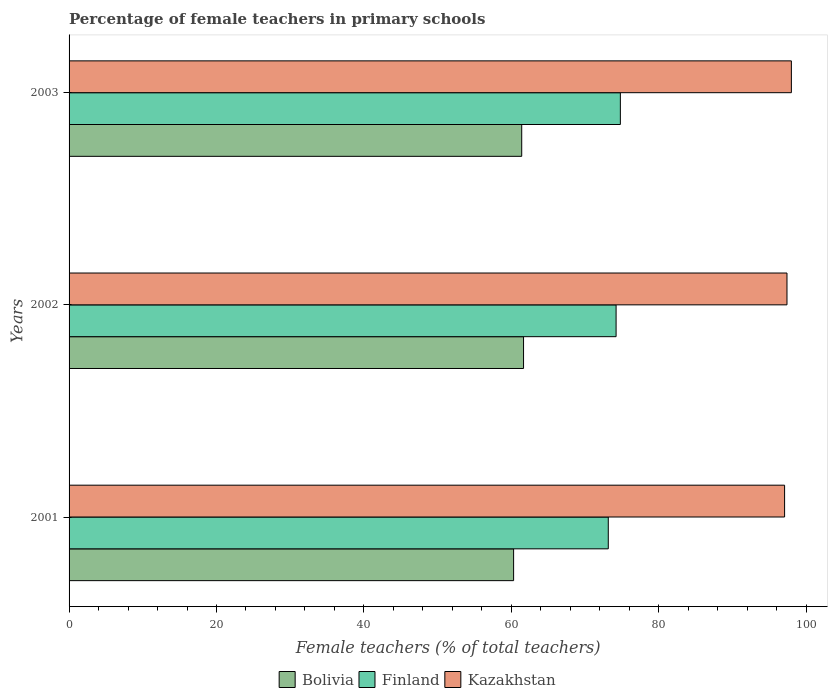How many groups of bars are there?
Ensure brevity in your answer.  3. Are the number of bars per tick equal to the number of legend labels?
Provide a succinct answer. Yes. How many bars are there on the 2nd tick from the bottom?
Give a very brief answer. 3. In how many cases, is the number of bars for a given year not equal to the number of legend labels?
Your response must be concise. 0. What is the percentage of female teachers in Kazakhstan in 2003?
Offer a terse response. 98. Across all years, what is the maximum percentage of female teachers in Finland?
Keep it short and to the point. 74.8. Across all years, what is the minimum percentage of female teachers in Kazakhstan?
Provide a short and direct response. 97.08. In which year was the percentage of female teachers in Kazakhstan maximum?
Make the answer very short. 2003. What is the total percentage of female teachers in Bolivia in the graph?
Provide a short and direct response. 183.4. What is the difference between the percentage of female teachers in Kazakhstan in 2001 and that in 2002?
Offer a terse response. -0.32. What is the difference between the percentage of female teachers in Finland in 2001 and the percentage of female teachers in Kazakhstan in 2003?
Make the answer very short. -24.84. What is the average percentage of female teachers in Finland per year?
Your response must be concise. 74.06. In the year 2001, what is the difference between the percentage of female teachers in Kazakhstan and percentage of female teachers in Finland?
Your answer should be very brief. 23.92. In how many years, is the percentage of female teachers in Kazakhstan greater than 64 %?
Offer a terse response. 3. What is the ratio of the percentage of female teachers in Bolivia in 2001 to that in 2002?
Give a very brief answer. 0.98. Is the percentage of female teachers in Bolivia in 2002 less than that in 2003?
Your answer should be very brief. No. Is the difference between the percentage of female teachers in Kazakhstan in 2001 and 2003 greater than the difference between the percentage of female teachers in Finland in 2001 and 2003?
Provide a succinct answer. Yes. What is the difference between the highest and the second highest percentage of female teachers in Bolivia?
Give a very brief answer. 0.25. What is the difference between the highest and the lowest percentage of female teachers in Kazakhstan?
Provide a short and direct response. 0.92. In how many years, is the percentage of female teachers in Kazakhstan greater than the average percentage of female teachers in Kazakhstan taken over all years?
Provide a short and direct response. 1. Is the sum of the percentage of female teachers in Bolivia in 2001 and 2002 greater than the maximum percentage of female teachers in Kazakhstan across all years?
Offer a terse response. Yes. What does the 1st bar from the top in 2001 represents?
Provide a succinct answer. Kazakhstan. What does the 1st bar from the bottom in 2001 represents?
Keep it short and to the point. Bolivia. Is it the case that in every year, the sum of the percentage of female teachers in Finland and percentage of female teachers in Kazakhstan is greater than the percentage of female teachers in Bolivia?
Offer a very short reply. Yes. Are all the bars in the graph horizontal?
Provide a succinct answer. Yes. What is the difference between two consecutive major ticks on the X-axis?
Offer a very short reply. 20. Does the graph contain any zero values?
Provide a short and direct response. No. Does the graph contain grids?
Offer a very short reply. No. Where does the legend appear in the graph?
Offer a terse response. Bottom center. What is the title of the graph?
Make the answer very short. Percentage of female teachers in primary schools. Does "Djibouti" appear as one of the legend labels in the graph?
Provide a short and direct response. No. What is the label or title of the X-axis?
Ensure brevity in your answer.  Female teachers (% of total teachers). What is the label or title of the Y-axis?
Ensure brevity in your answer.  Years. What is the Female teachers (% of total teachers) of Bolivia in 2001?
Make the answer very short. 60.32. What is the Female teachers (% of total teachers) in Finland in 2001?
Make the answer very short. 73.16. What is the Female teachers (% of total teachers) in Kazakhstan in 2001?
Give a very brief answer. 97.08. What is the Female teachers (% of total teachers) in Bolivia in 2002?
Provide a short and direct response. 61.66. What is the Female teachers (% of total teachers) in Finland in 2002?
Provide a succinct answer. 74.22. What is the Female teachers (% of total teachers) of Kazakhstan in 2002?
Your response must be concise. 97.41. What is the Female teachers (% of total teachers) of Bolivia in 2003?
Offer a very short reply. 61.42. What is the Female teachers (% of total teachers) of Finland in 2003?
Keep it short and to the point. 74.8. What is the Female teachers (% of total teachers) in Kazakhstan in 2003?
Your answer should be compact. 98. Across all years, what is the maximum Female teachers (% of total teachers) in Bolivia?
Offer a very short reply. 61.66. Across all years, what is the maximum Female teachers (% of total teachers) of Finland?
Your response must be concise. 74.8. Across all years, what is the maximum Female teachers (% of total teachers) of Kazakhstan?
Offer a very short reply. 98. Across all years, what is the minimum Female teachers (% of total teachers) of Bolivia?
Offer a terse response. 60.32. Across all years, what is the minimum Female teachers (% of total teachers) of Finland?
Provide a succinct answer. 73.16. Across all years, what is the minimum Female teachers (% of total teachers) in Kazakhstan?
Give a very brief answer. 97.08. What is the total Female teachers (% of total teachers) in Bolivia in the graph?
Keep it short and to the point. 183.4. What is the total Female teachers (% of total teachers) in Finland in the graph?
Provide a short and direct response. 222.18. What is the total Female teachers (% of total teachers) in Kazakhstan in the graph?
Your response must be concise. 292.49. What is the difference between the Female teachers (% of total teachers) of Bolivia in 2001 and that in 2002?
Your answer should be very brief. -1.35. What is the difference between the Female teachers (% of total teachers) in Finland in 2001 and that in 2002?
Give a very brief answer. -1.06. What is the difference between the Female teachers (% of total teachers) in Kazakhstan in 2001 and that in 2002?
Your answer should be very brief. -0.32. What is the difference between the Female teachers (% of total teachers) of Bolivia in 2001 and that in 2003?
Your response must be concise. -1.1. What is the difference between the Female teachers (% of total teachers) in Finland in 2001 and that in 2003?
Provide a succinct answer. -1.64. What is the difference between the Female teachers (% of total teachers) in Kazakhstan in 2001 and that in 2003?
Your response must be concise. -0.92. What is the difference between the Female teachers (% of total teachers) of Bolivia in 2002 and that in 2003?
Give a very brief answer. 0.25. What is the difference between the Female teachers (% of total teachers) of Finland in 2002 and that in 2003?
Ensure brevity in your answer.  -0.58. What is the difference between the Female teachers (% of total teachers) of Kazakhstan in 2002 and that in 2003?
Offer a terse response. -0.6. What is the difference between the Female teachers (% of total teachers) in Bolivia in 2001 and the Female teachers (% of total teachers) in Finland in 2002?
Offer a terse response. -13.9. What is the difference between the Female teachers (% of total teachers) in Bolivia in 2001 and the Female teachers (% of total teachers) in Kazakhstan in 2002?
Your answer should be very brief. -37.09. What is the difference between the Female teachers (% of total teachers) in Finland in 2001 and the Female teachers (% of total teachers) in Kazakhstan in 2002?
Give a very brief answer. -24.25. What is the difference between the Female teachers (% of total teachers) in Bolivia in 2001 and the Female teachers (% of total teachers) in Finland in 2003?
Offer a terse response. -14.48. What is the difference between the Female teachers (% of total teachers) of Bolivia in 2001 and the Female teachers (% of total teachers) of Kazakhstan in 2003?
Offer a very short reply. -37.69. What is the difference between the Female teachers (% of total teachers) in Finland in 2001 and the Female teachers (% of total teachers) in Kazakhstan in 2003?
Your response must be concise. -24.84. What is the difference between the Female teachers (% of total teachers) in Bolivia in 2002 and the Female teachers (% of total teachers) in Finland in 2003?
Your response must be concise. -13.14. What is the difference between the Female teachers (% of total teachers) of Bolivia in 2002 and the Female teachers (% of total teachers) of Kazakhstan in 2003?
Offer a very short reply. -36.34. What is the difference between the Female teachers (% of total teachers) in Finland in 2002 and the Female teachers (% of total teachers) in Kazakhstan in 2003?
Your answer should be compact. -23.78. What is the average Female teachers (% of total teachers) of Bolivia per year?
Offer a very short reply. 61.13. What is the average Female teachers (% of total teachers) of Finland per year?
Your answer should be very brief. 74.06. What is the average Female teachers (% of total teachers) of Kazakhstan per year?
Your response must be concise. 97.5. In the year 2001, what is the difference between the Female teachers (% of total teachers) in Bolivia and Female teachers (% of total teachers) in Finland?
Your response must be concise. -12.84. In the year 2001, what is the difference between the Female teachers (% of total teachers) in Bolivia and Female teachers (% of total teachers) in Kazakhstan?
Keep it short and to the point. -36.77. In the year 2001, what is the difference between the Female teachers (% of total teachers) of Finland and Female teachers (% of total teachers) of Kazakhstan?
Offer a very short reply. -23.92. In the year 2002, what is the difference between the Female teachers (% of total teachers) of Bolivia and Female teachers (% of total teachers) of Finland?
Your response must be concise. -12.56. In the year 2002, what is the difference between the Female teachers (% of total teachers) of Bolivia and Female teachers (% of total teachers) of Kazakhstan?
Your answer should be very brief. -35.74. In the year 2002, what is the difference between the Female teachers (% of total teachers) of Finland and Female teachers (% of total teachers) of Kazakhstan?
Keep it short and to the point. -23.19. In the year 2003, what is the difference between the Female teachers (% of total teachers) of Bolivia and Female teachers (% of total teachers) of Finland?
Provide a succinct answer. -13.38. In the year 2003, what is the difference between the Female teachers (% of total teachers) of Bolivia and Female teachers (% of total teachers) of Kazakhstan?
Ensure brevity in your answer.  -36.59. In the year 2003, what is the difference between the Female teachers (% of total teachers) of Finland and Female teachers (% of total teachers) of Kazakhstan?
Your response must be concise. -23.2. What is the ratio of the Female teachers (% of total teachers) of Bolivia in 2001 to that in 2002?
Give a very brief answer. 0.98. What is the ratio of the Female teachers (% of total teachers) in Finland in 2001 to that in 2002?
Your answer should be very brief. 0.99. What is the ratio of the Female teachers (% of total teachers) of Bolivia in 2001 to that in 2003?
Provide a succinct answer. 0.98. What is the ratio of the Female teachers (% of total teachers) of Finland in 2001 to that in 2003?
Give a very brief answer. 0.98. What is the ratio of the Female teachers (% of total teachers) of Kazakhstan in 2001 to that in 2003?
Offer a terse response. 0.99. What is the ratio of the Female teachers (% of total teachers) of Bolivia in 2002 to that in 2003?
Ensure brevity in your answer.  1. What is the ratio of the Female teachers (% of total teachers) in Finland in 2002 to that in 2003?
Make the answer very short. 0.99. What is the ratio of the Female teachers (% of total teachers) in Kazakhstan in 2002 to that in 2003?
Give a very brief answer. 0.99. What is the difference between the highest and the second highest Female teachers (% of total teachers) of Bolivia?
Give a very brief answer. 0.25. What is the difference between the highest and the second highest Female teachers (% of total teachers) in Finland?
Keep it short and to the point. 0.58. What is the difference between the highest and the second highest Female teachers (% of total teachers) of Kazakhstan?
Your answer should be compact. 0.6. What is the difference between the highest and the lowest Female teachers (% of total teachers) of Bolivia?
Your answer should be compact. 1.35. What is the difference between the highest and the lowest Female teachers (% of total teachers) of Finland?
Keep it short and to the point. 1.64. What is the difference between the highest and the lowest Female teachers (% of total teachers) of Kazakhstan?
Provide a succinct answer. 0.92. 